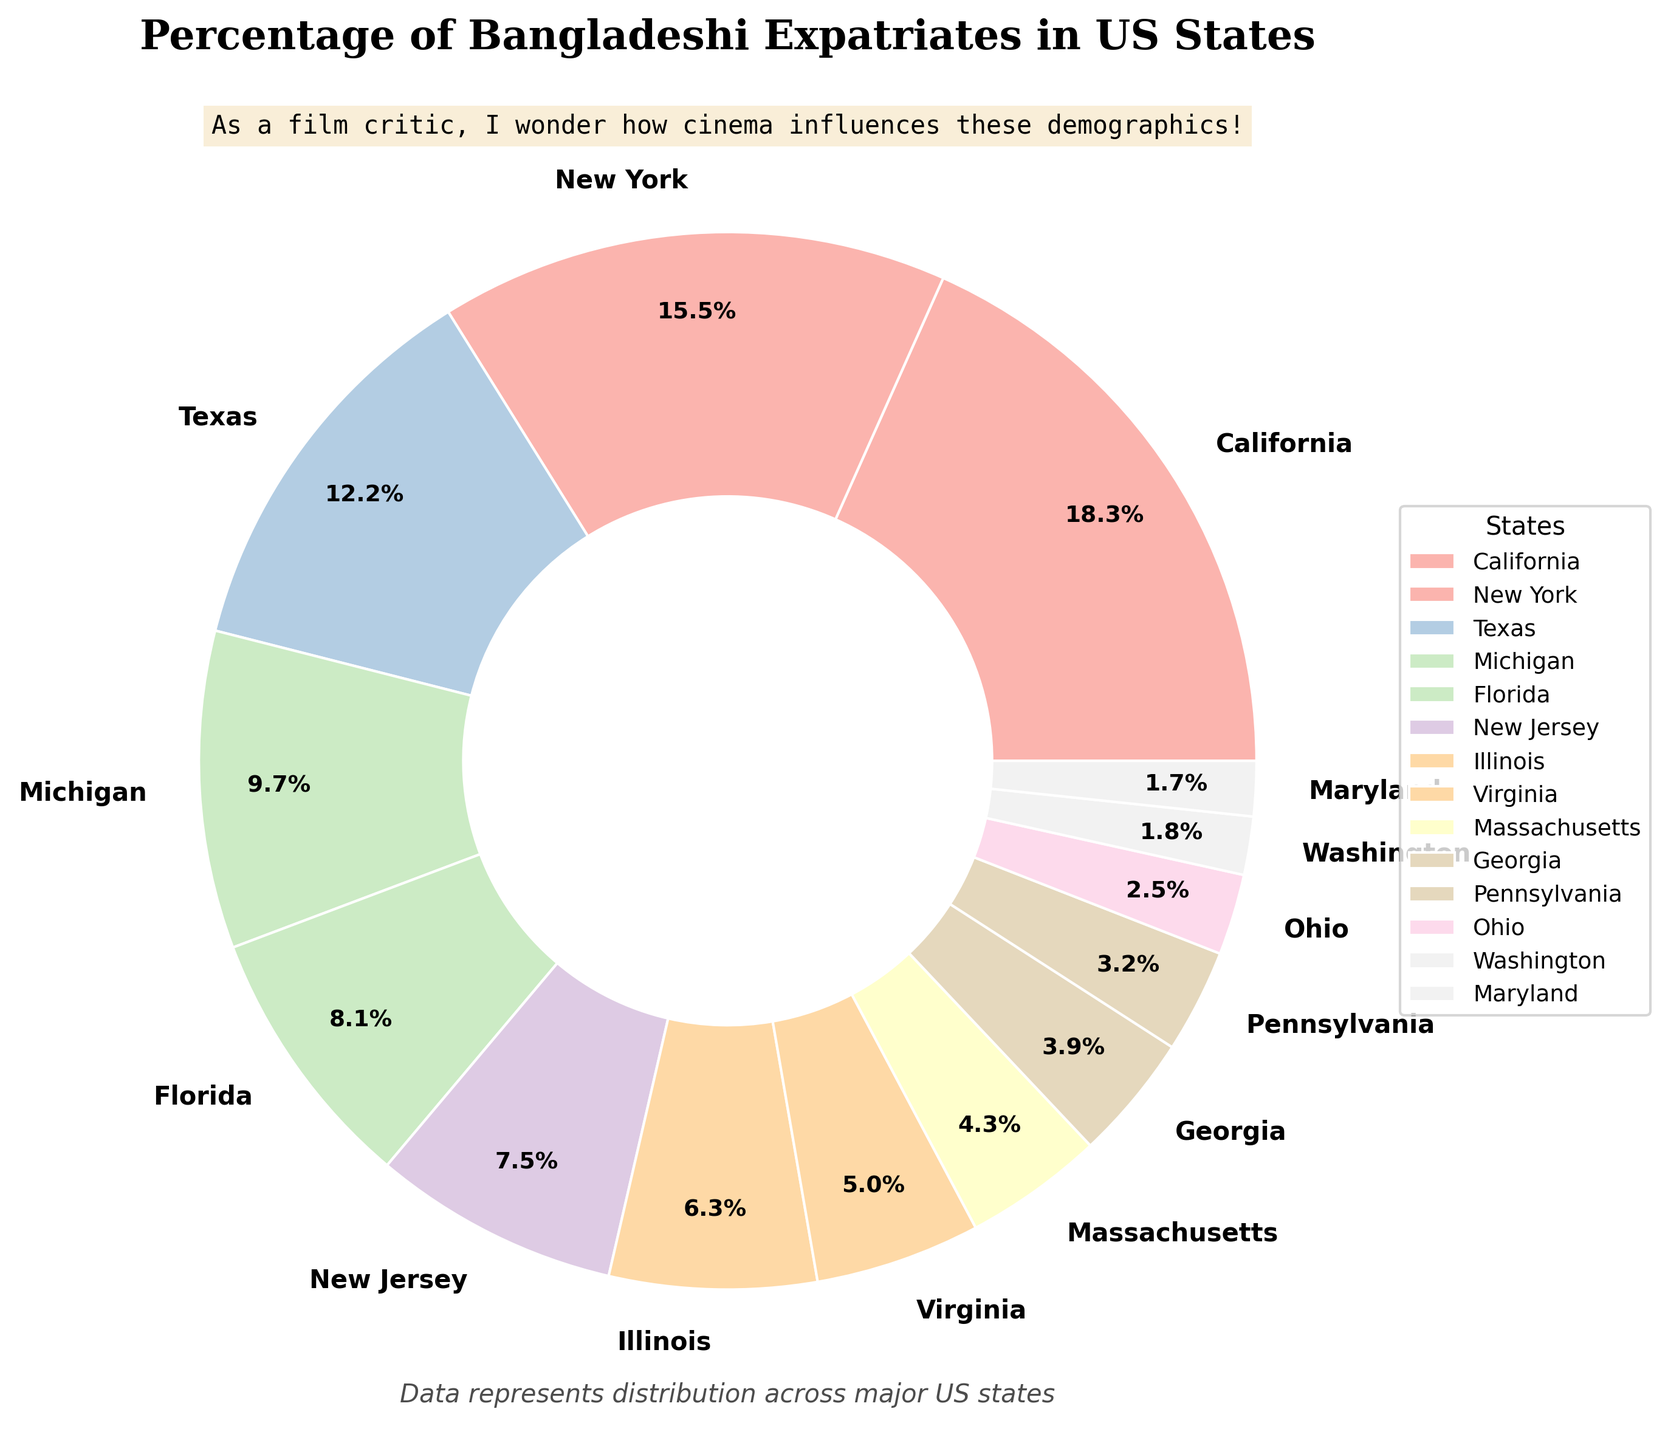Which state has the largest percentage of Bangladeshi expatriates? The largest wedge in the pie chart can be easily identified by its size and the accompanying percentage label. California has the largest wedge marked with 18.5%.
Answer: California How does the percentage of Bangladeshi expatriates in New York compare to that in Florida? Locate the wedges for New York and Florida on the pie chart and compare their percentage labels. New York is 15.7% and Florida is 8.2%. New York has a higher percentage.
Answer: New York What is the combined percentage of Bangladeshi expatriates in Texas and New Jersey? First, find the percentages for Texas and New Jersey in the chart: Texas is 12.3% and New Jersey is 7.6%. Add these values together to find the combined percentage: 12.3 + 7.6 = 19.9%.
Answer: 19.9% Which three states have the smallest percentages of Bangladeshi expatriates? Identify the three smallest wedges in the chart by their size and labels. The states with the smallest percentages are Maryland (1.7%), Washington (1.8%), and Ohio (2.5%).
Answer: Maryland, Washington, Ohio What is the difference in percentage between Michigan and Illinois? Locate the percentages for Michigan and Illinois in the pie chart: Michigan is 9.8% and Illinois is 6.4%. Subtract the smaller percentage from the larger one: 9.8 - 6.4 = 3.4%.
Answer: 3.4% What is the average percentage of Bangladeshi expatriates in Massachusetts and Georgia? Find the percentages for Massachusetts and Georgia: Massachusetts is 4.3% and Georgia is 3.9%. Add these values and divide by 2 to find the average: (4.3 + 3.9) / 2 = 4.1%.
Answer: 4.1% Which state is represented by a wedge with a proportion close to 5%? In the pie chart, look for a wedge that has a percentage label close to 5%. Virginia has a wedge labeled with 5.1%.
Answer: Virginia How many states have a percentage greater than 10%? Count the number of wedges in the pie chart with labels indicating percentages greater than 10%. The states are California (18.5%), New York (15.7%), and Texas (12.3%), resulting in a total of 3 states.
Answer: 3 What is the total percentage of Bangladeshi expatriates living in Illinois, Virginia, and Massachusetts combined? Locate the percentages for Illinois (6.4%), Virginia (5.1%), and Massachusetts (4.3%). Add these values together: 6.4 + 5.1 + 4.3 = 15.8%.
Answer: 15.8% Does Florida have more or less Bangladeshi expatriates compared to New Jersey? Compare the wedges labeled Florida (8.2%) and New Jersey (7.6%) in the pie chart to determine which one has a higher percentage. Florida has a higher percentage.
Answer: More 